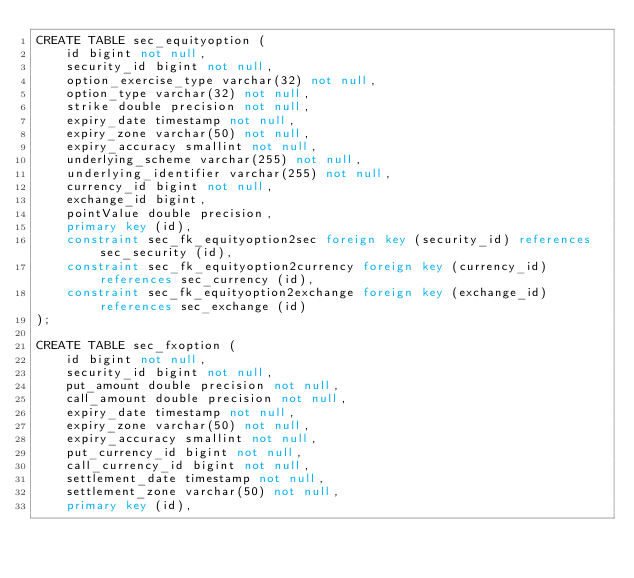<code> <loc_0><loc_0><loc_500><loc_500><_SQL_>CREATE TABLE sec_equityoption (
    id bigint not null,
    security_id bigint not null,
    option_exercise_type varchar(32) not null,
    option_type varchar(32) not null,
    strike double precision not null,
    expiry_date timestamp not null,
    expiry_zone varchar(50) not null,
    expiry_accuracy smallint not null,
    underlying_scheme varchar(255) not null,
    underlying_identifier varchar(255) not null,
    currency_id bigint not null,
    exchange_id bigint,
    pointValue double precision,
    primary key (id),
    constraint sec_fk_equityoption2sec foreign key (security_id) references sec_security (id),
    constraint sec_fk_equityoption2currency foreign key (currency_id) references sec_currency (id),
    constraint sec_fk_equityoption2exchange foreign key (exchange_id) references sec_exchange (id)
);

CREATE TABLE sec_fxoption (
    id bigint not null,
    security_id bigint not null,
    put_amount double precision not null,
    call_amount double precision not null,
    expiry_date timestamp not null,
    expiry_zone varchar(50) not null,
    expiry_accuracy smallint not null,
    put_currency_id bigint not null,
    call_currency_id bigint not null,
    settlement_date timestamp not null,
    settlement_zone varchar(50) not null,
    primary key (id),</code> 